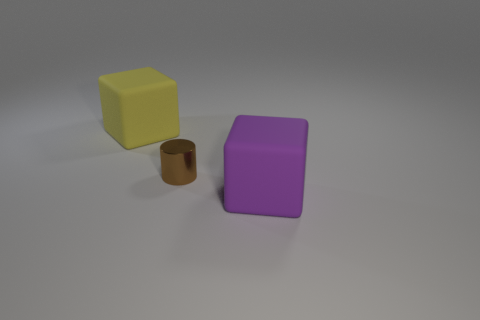Subtract all red cubes. Subtract all cyan cylinders. How many cubes are left? 2 Add 2 yellow metallic spheres. How many objects exist? 5 Subtract all cubes. How many objects are left? 1 Subtract all tiny purple metallic cubes. Subtract all rubber blocks. How many objects are left? 1 Add 2 metal cylinders. How many metal cylinders are left? 3 Add 2 yellow cubes. How many yellow cubes exist? 3 Subtract 1 purple blocks. How many objects are left? 2 